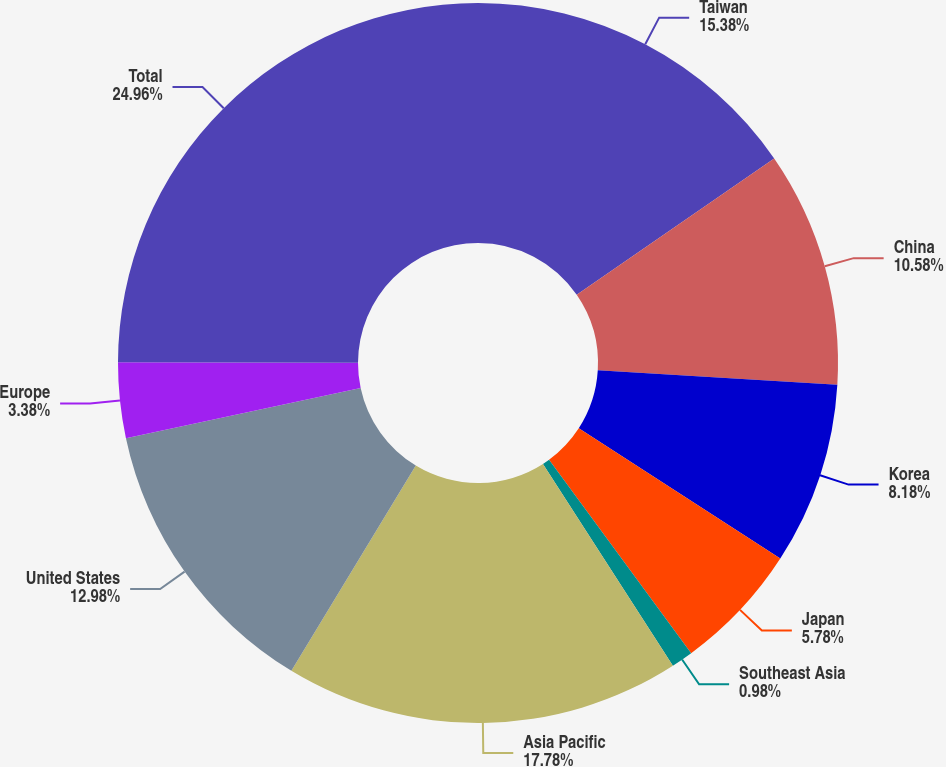Convert chart to OTSL. <chart><loc_0><loc_0><loc_500><loc_500><pie_chart><fcel>Taiwan<fcel>China<fcel>Korea<fcel>Japan<fcel>Southeast Asia<fcel>Asia Pacific<fcel>United States<fcel>Europe<fcel>Total<nl><fcel>15.38%<fcel>10.58%<fcel>8.18%<fcel>5.78%<fcel>0.98%<fcel>17.78%<fcel>12.98%<fcel>3.38%<fcel>24.97%<nl></chart> 